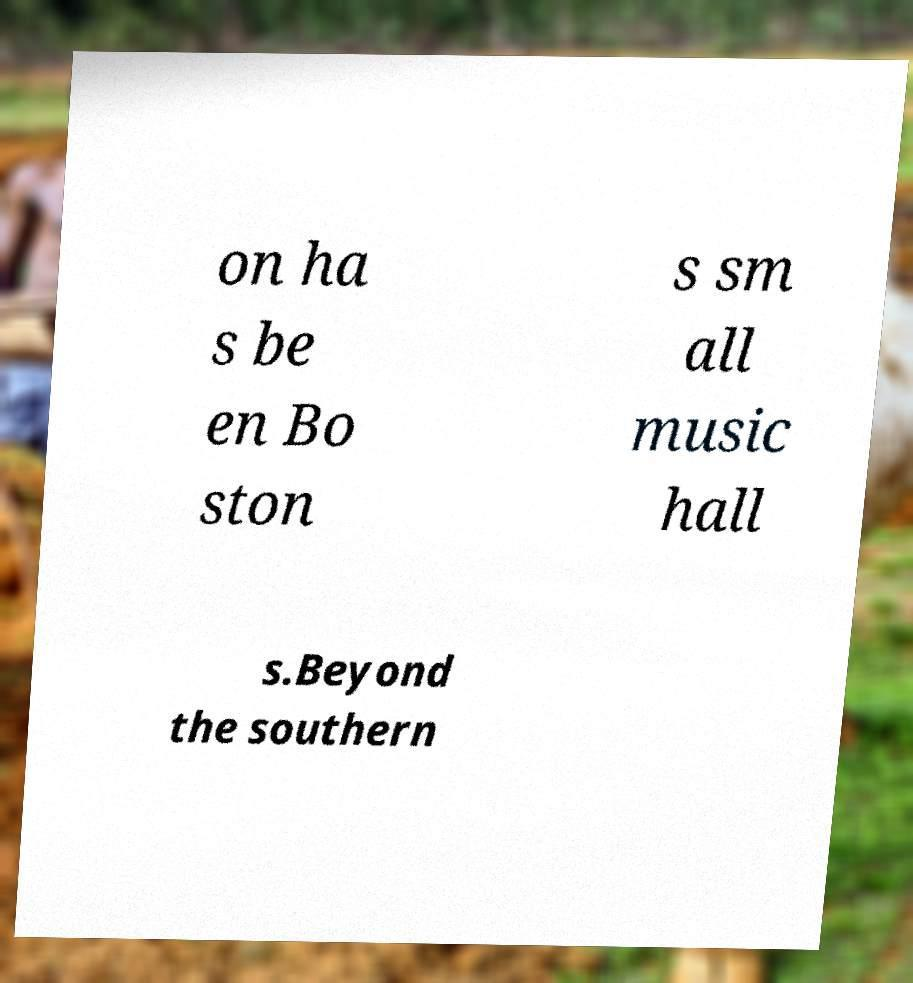Could you assist in decoding the text presented in this image and type it out clearly? on ha s be en Bo ston s sm all music hall s.Beyond the southern 